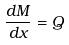<formula> <loc_0><loc_0><loc_500><loc_500>\frac { d M } { d x } = Q</formula> 